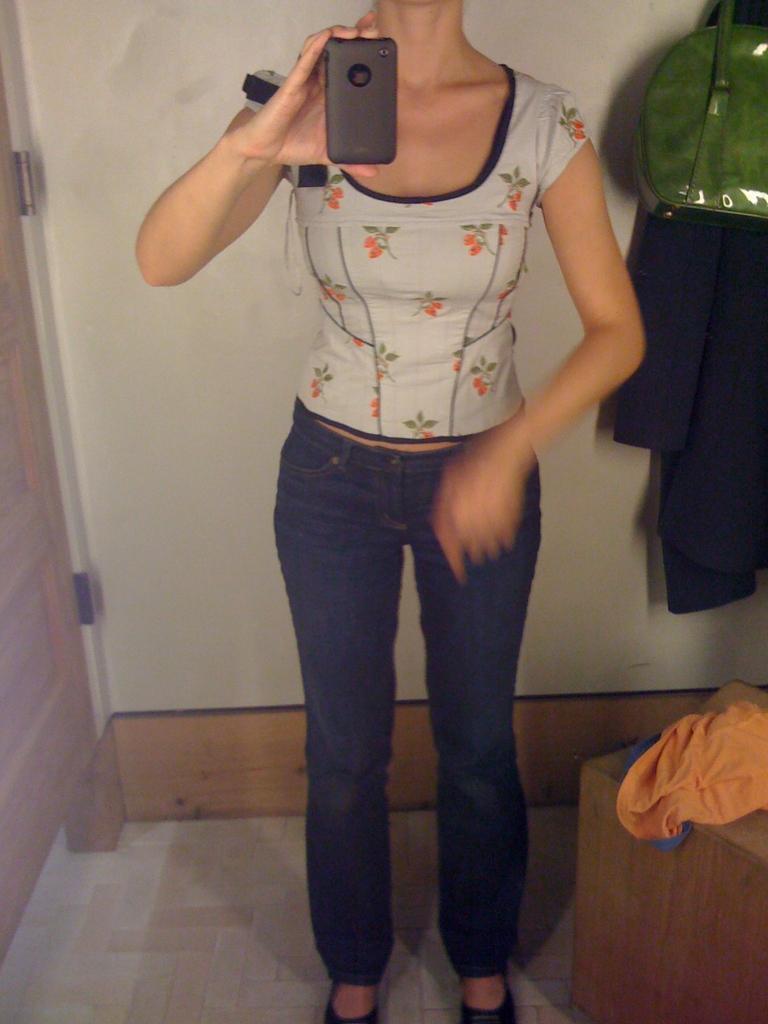Describe this image in one or two sentences. There is a woman standing and holding a mobile,beside this woman we can see clothes on wooden surface. In the background we can see wall,cloth and green bag. 